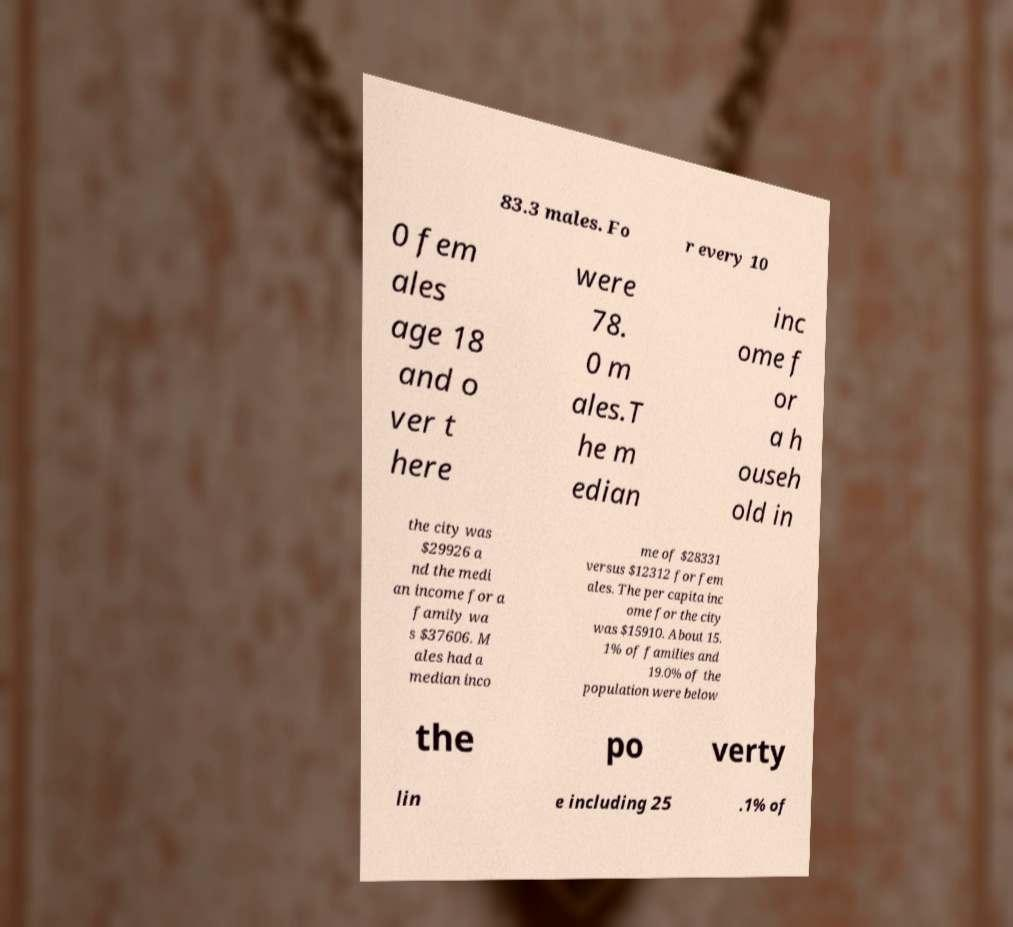Please read and relay the text visible in this image. What does it say? 83.3 males. Fo r every 10 0 fem ales age 18 and o ver t here were 78. 0 m ales.T he m edian inc ome f or a h ouseh old in the city was $29926 a nd the medi an income for a family wa s $37606. M ales had a median inco me of $28331 versus $12312 for fem ales. The per capita inc ome for the city was $15910. About 15. 1% of families and 19.0% of the population were below the po verty lin e including 25 .1% of 